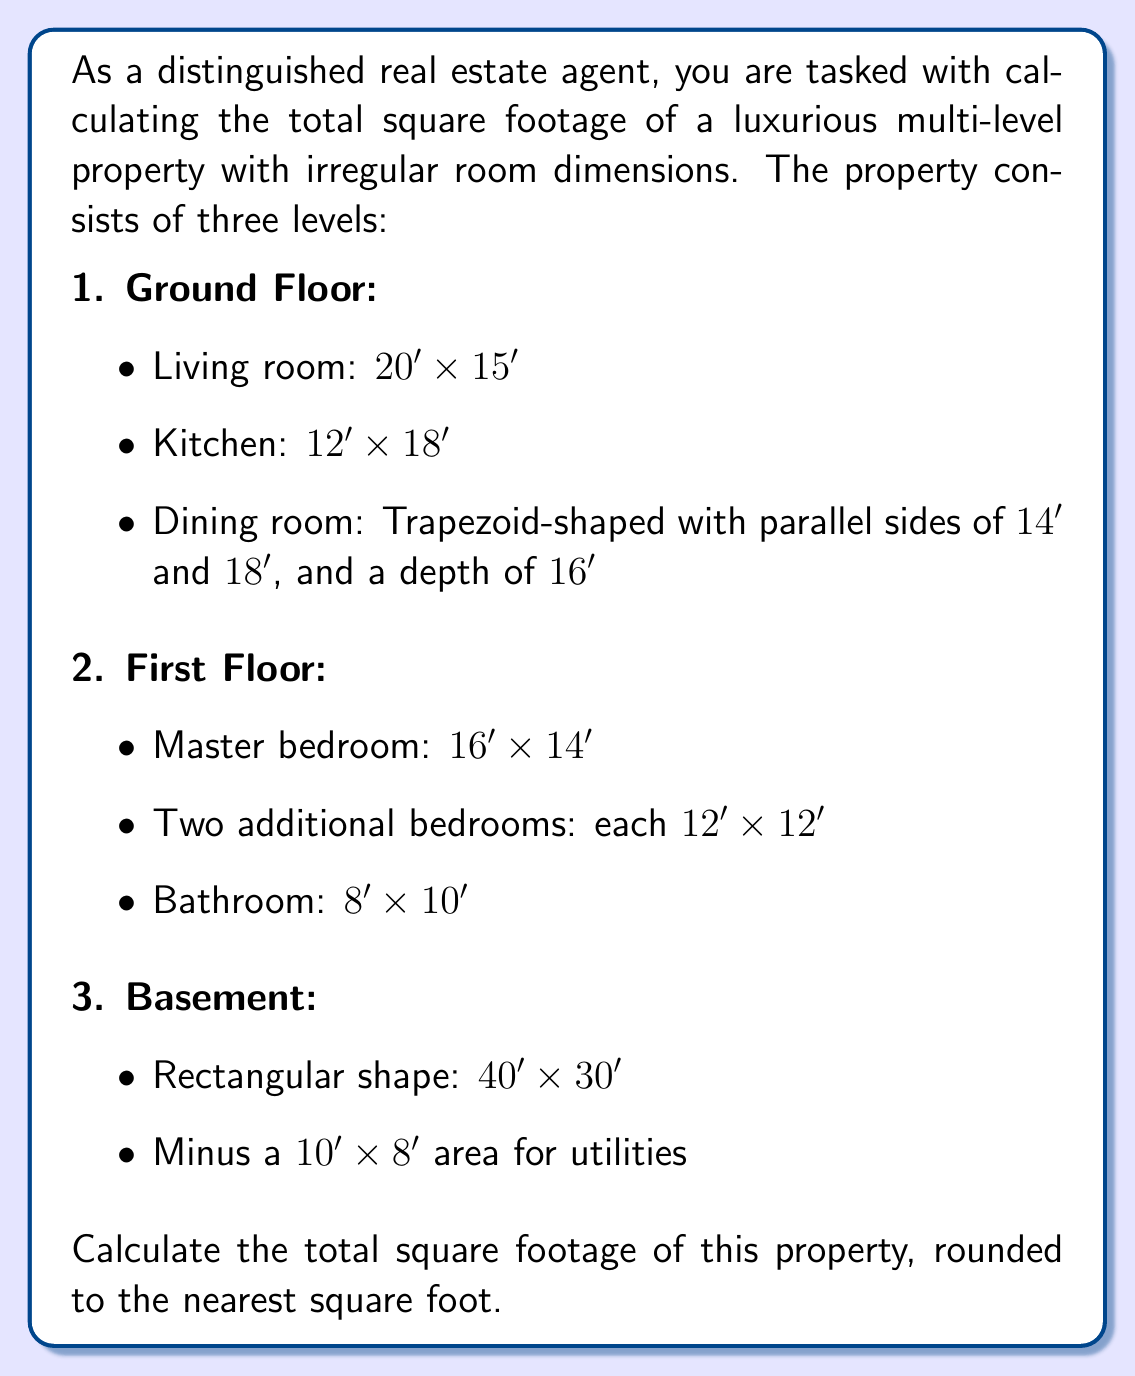Solve this math problem. To solve this problem, we need to calculate the area of each room and then sum them up. Let's break it down by floor:

1. Ground Floor:
   - Living room: $A = 20' \times 15' = 300 \text{ sq ft}$
   - Kitchen: $A = 12' \times 18' = 216 \text{ sq ft}$
   - Dining room (trapezoid): $A = \frac{1}{2}(a+b)h = \frac{1}{2}(14'+18') \times 16' = 256 \text{ sq ft}$

   Ground Floor Total: $300 + 216 + 256 = 772 \text{ sq ft}$

2. First Floor:
   - Master bedroom: $A = 16' \times 14' = 224 \text{ sq ft}$
   - Two additional bedrooms: $2 \times (12' \times 12') = 2 \times 144 = 288 \text{ sq ft}$
   - Bathroom: $A = 8' \times 10' = 80 \text{ sq ft}$

   First Floor Total: $224 + 288 + 80 = 592 \text{ sq ft}$

3. Basement:
   - Total area: $A = 40' \times 30' = 1200 \text{ sq ft}$
   - Utilities area: $A = 10' \times 8' = 80 \text{ sq ft}$
   - Usable basement area: $1200 - 80 = 1120 \text{ sq ft}$

Now, we sum up the total square footage from all three levels:

$$\text{Total sq ft} = 772 + 592 + 1120 = 2484 \text{ sq ft}$$

Rounding to the nearest square foot: $2484 \text{ sq ft}$
Answer: $2484 \text{ sq ft}$ 